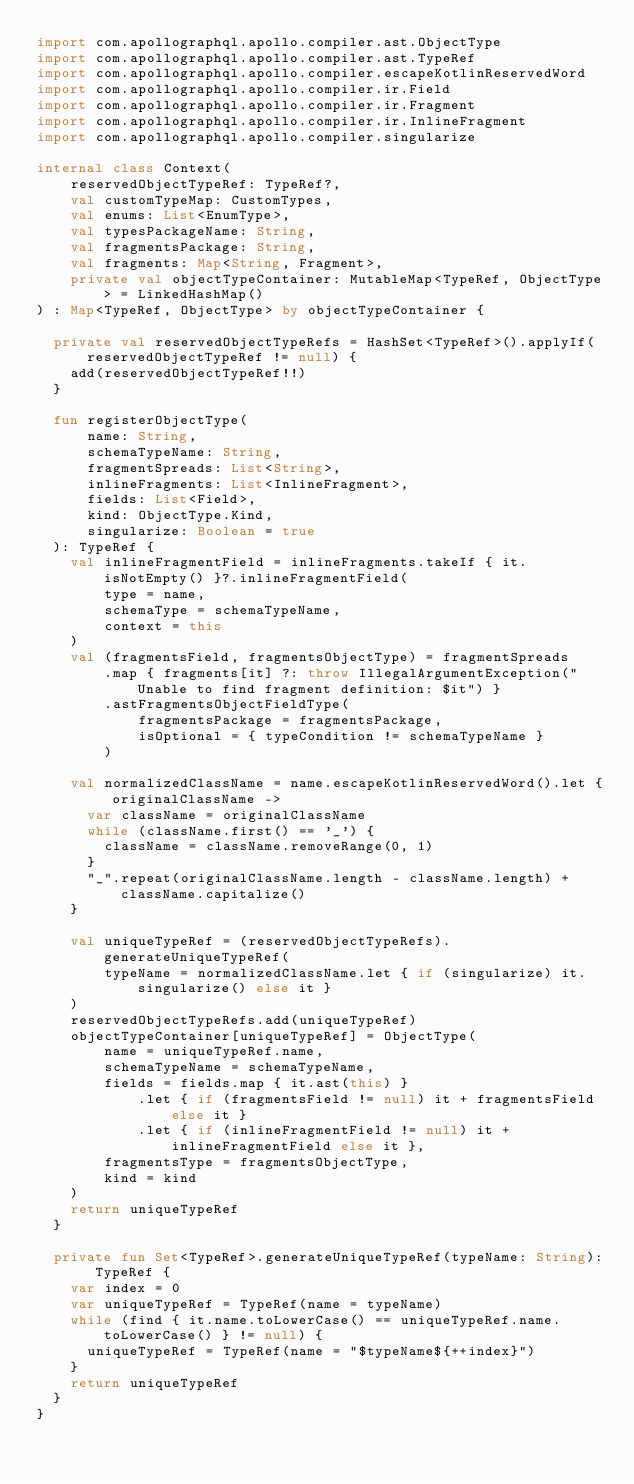Convert code to text. <code><loc_0><loc_0><loc_500><loc_500><_Kotlin_>import com.apollographql.apollo.compiler.ast.ObjectType
import com.apollographql.apollo.compiler.ast.TypeRef
import com.apollographql.apollo.compiler.escapeKotlinReservedWord
import com.apollographql.apollo.compiler.ir.Field
import com.apollographql.apollo.compiler.ir.Fragment
import com.apollographql.apollo.compiler.ir.InlineFragment
import com.apollographql.apollo.compiler.singularize

internal class Context(
    reservedObjectTypeRef: TypeRef?,
    val customTypeMap: CustomTypes,
    val enums: List<EnumType>,
    val typesPackageName: String,
    val fragmentsPackage: String,
    val fragments: Map<String, Fragment>,
    private val objectTypeContainer: MutableMap<TypeRef, ObjectType> = LinkedHashMap()
) : Map<TypeRef, ObjectType> by objectTypeContainer {

  private val reservedObjectTypeRefs = HashSet<TypeRef>().applyIf(reservedObjectTypeRef != null) {
    add(reservedObjectTypeRef!!)
  }

  fun registerObjectType(
      name: String,
      schemaTypeName: String,
      fragmentSpreads: List<String>,
      inlineFragments: List<InlineFragment>,
      fields: List<Field>,
      kind: ObjectType.Kind,
      singularize: Boolean = true
  ): TypeRef {
    val inlineFragmentField = inlineFragments.takeIf { it.isNotEmpty() }?.inlineFragmentField(
        type = name,
        schemaType = schemaTypeName,
        context = this
    )
    val (fragmentsField, fragmentsObjectType) = fragmentSpreads
        .map { fragments[it] ?: throw IllegalArgumentException("Unable to find fragment definition: $it") }
        .astFragmentsObjectFieldType(
            fragmentsPackage = fragmentsPackage,
            isOptional = { typeCondition != schemaTypeName }
        )

    val normalizedClassName = name.escapeKotlinReservedWord().let { originalClassName ->
      var className = originalClassName
      while (className.first() == '_') {
        className = className.removeRange(0, 1)
      }
      "_".repeat(originalClassName.length - className.length) + className.capitalize()
    }

    val uniqueTypeRef = (reservedObjectTypeRefs).generateUniqueTypeRef(
        typeName = normalizedClassName.let { if (singularize) it.singularize() else it }
    )
    reservedObjectTypeRefs.add(uniqueTypeRef)
    objectTypeContainer[uniqueTypeRef] = ObjectType(
        name = uniqueTypeRef.name,
        schemaTypeName = schemaTypeName,
        fields = fields.map { it.ast(this) }
            .let { if (fragmentsField != null) it + fragmentsField else it }
            .let { if (inlineFragmentField != null) it + inlineFragmentField else it },
        fragmentsType = fragmentsObjectType,
        kind = kind
    )
    return uniqueTypeRef
  }

  private fun Set<TypeRef>.generateUniqueTypeRef(typeName: String): TypeRef {
    var index = 0
    var uniqueTypeRef = TypeRef(name = typeName)
    while (find { it.name.toLowerCase() == uniqueTypeRef.name.toLowerCase() } != null) {
      uniqueTypeRef = TypeRef(name = "$typeName${++index}")
    }
    return uniqueTypeRef
  }
}
</code> 